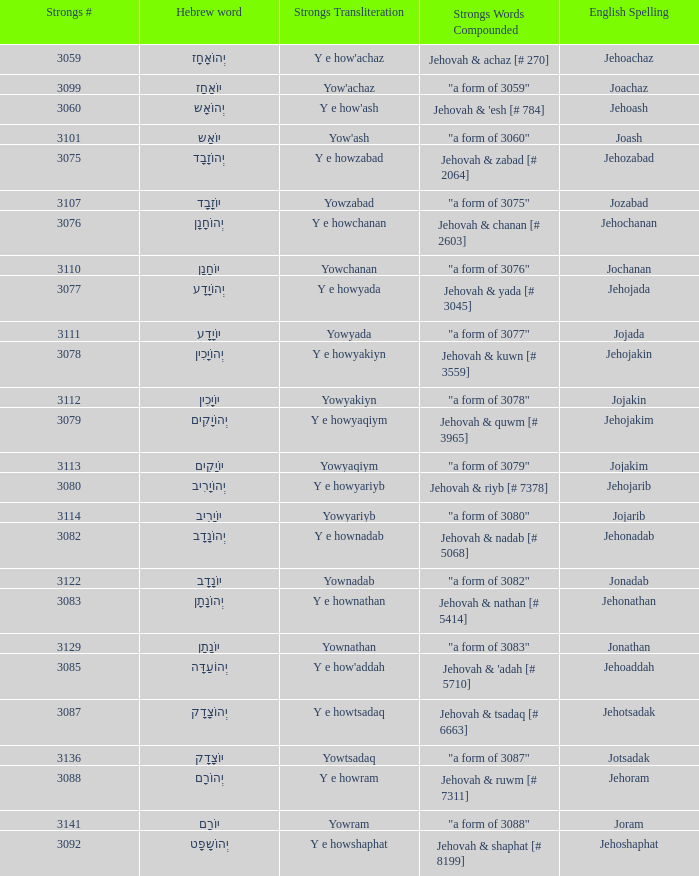What is the english spelling of the word that has the strongs trasliteration of y e howram? Jehoram. 